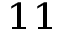<formula> <loc_0><loc_0><loc_500><loc_500>^ { 1 1 }</formula> 